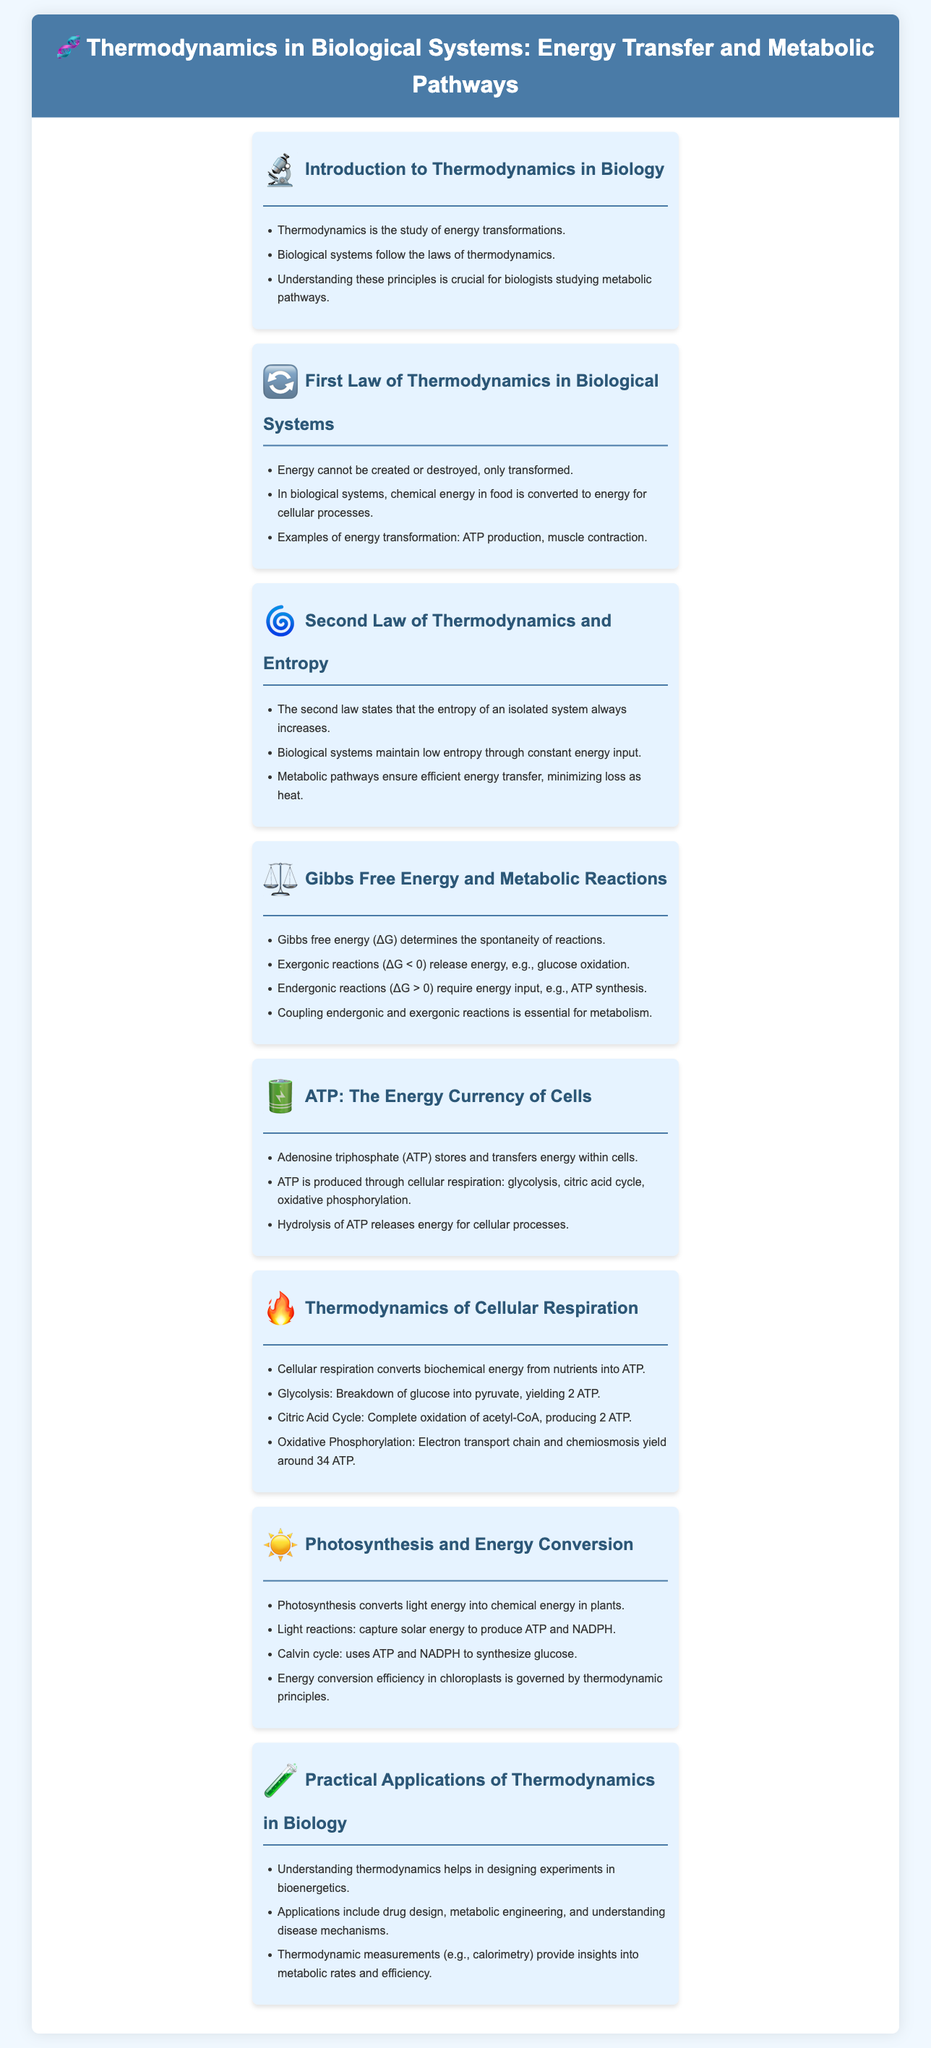What is the focus of the infographic? The infographic focuses on thermodynamics in biological systems, specifically energy transfer and metabolic pathways.
Answer: thermodynamics in biological systems What does the first law of thermodynamics state? The first law of thermodynamics states that energy cannot be created or destroyed, only transformed.
Answer: energy cannot be created or destroyed What is Gibbs free energy (ΔG) used to determine? Gibbs free energy (ΔG) is used to determine the spontaneity of reactions.
Answer: spontaneity of reactions How many ATP are produced during glycolysis? Glycolysis produces 2 ATP.
Answer: 2 ATP What is the main energy currency of cells? The main energy currency of cells is adenosine triphosphate (ATP).
Answer: adenosine triphosphate (ATP) Which process converts light energy into chemical energy? Photosynthesis converts light energy into chemical energy.
Answer: Photosynthesis How is ATP produced in cellular respiration's oxidative phosphorylation step? ATP is produced in oxidative phosphorylation through electron transport chain and chemiosmosis.
Answer: electron transport chain and chemiosmosis What role do metabolic pathways play in biological systems? Metabolic pathways ensure efficient energy transfer, minimizing loss as heat.
Answer: efficient energy transfer What is a practical application of thermodynamics in biology? A practical application is designing experiments in bioenergetics.
Answer: designing experiments in bioenergetics 